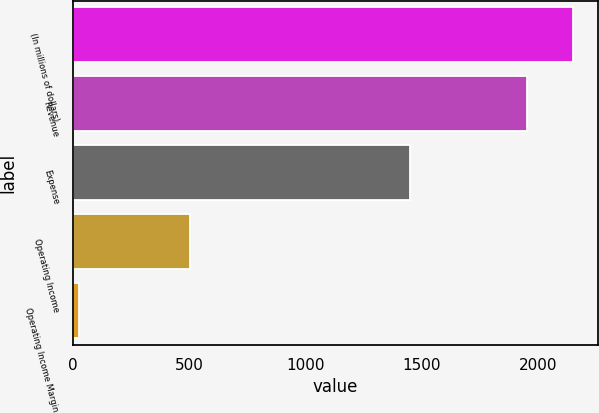Convert chart. <chart><loc_0><loc_0><loc_500><loc_500><bar_chart><fcel>(In millions of dollars)<fcel>Revenue<fcel>Expense<fcel>Operating Income<fcel>Operating Income Margin<nl><fcel>2152.73<fcel>1955<fcel>1452<fcel>503<fcel>25.7<nl></chart> 